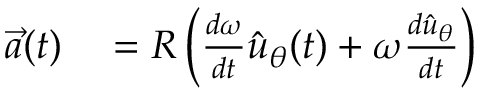Convert formula to latex. <formula><loc_0><loc_0><loc_500><loc_500>\begin{array} { r l } { { \vec { a } } ( t ) } & = R \left ( { \frac { d \omega } { d t } } { \hat { u } } _ { \theta } ( t ) + \omega { \frac { d { \hat { u } } _ { \theta } } { d t } } \right ) } \end{array}</formula> 